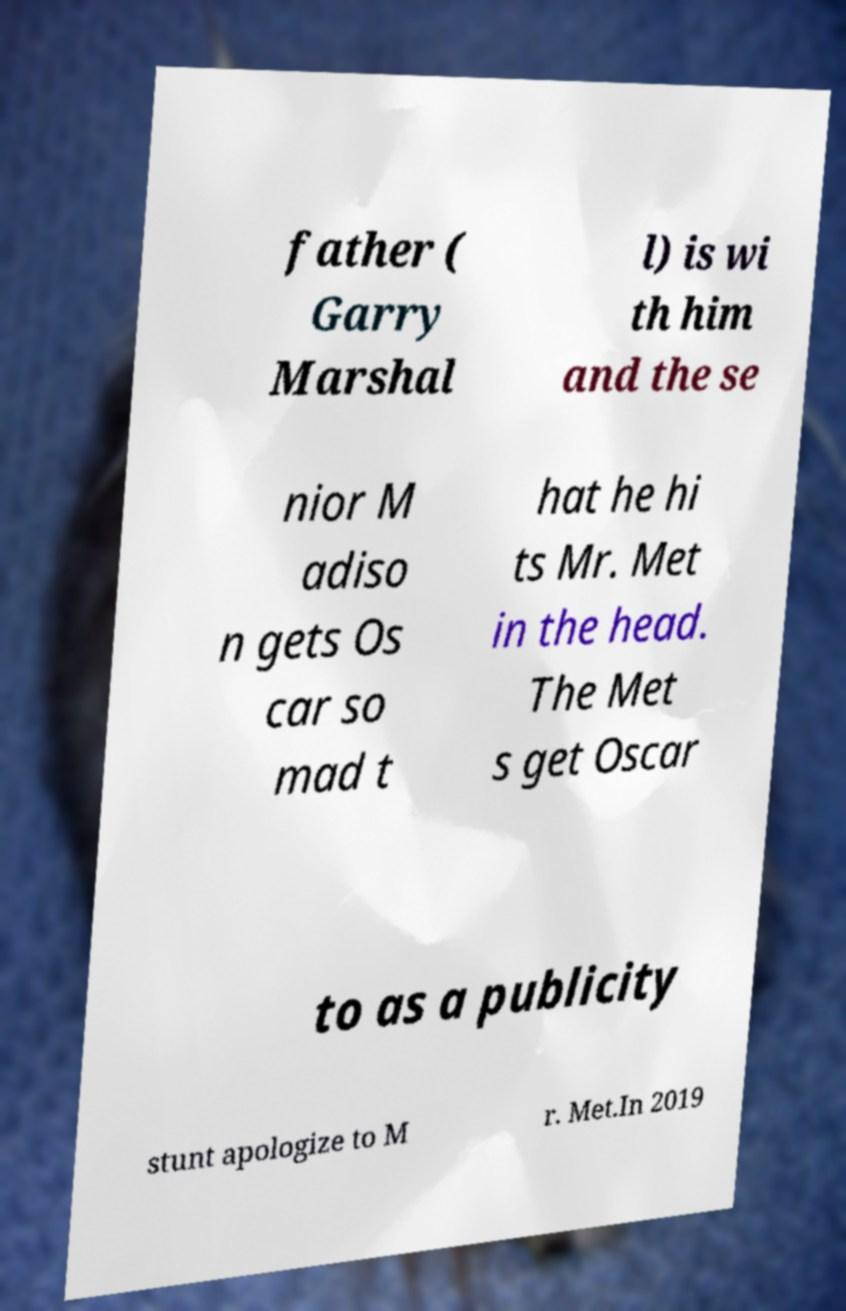Could you assist in decoding the text presented in this image and type it out clearly? father ( Garry Marshal l) is wi th him and the se nior M adiso n gets Os car so mad t hat he hi ts Mr. Met in the head. The Met s get Oscar to as a publicity stunt apologize to M r. Met.In 2019 